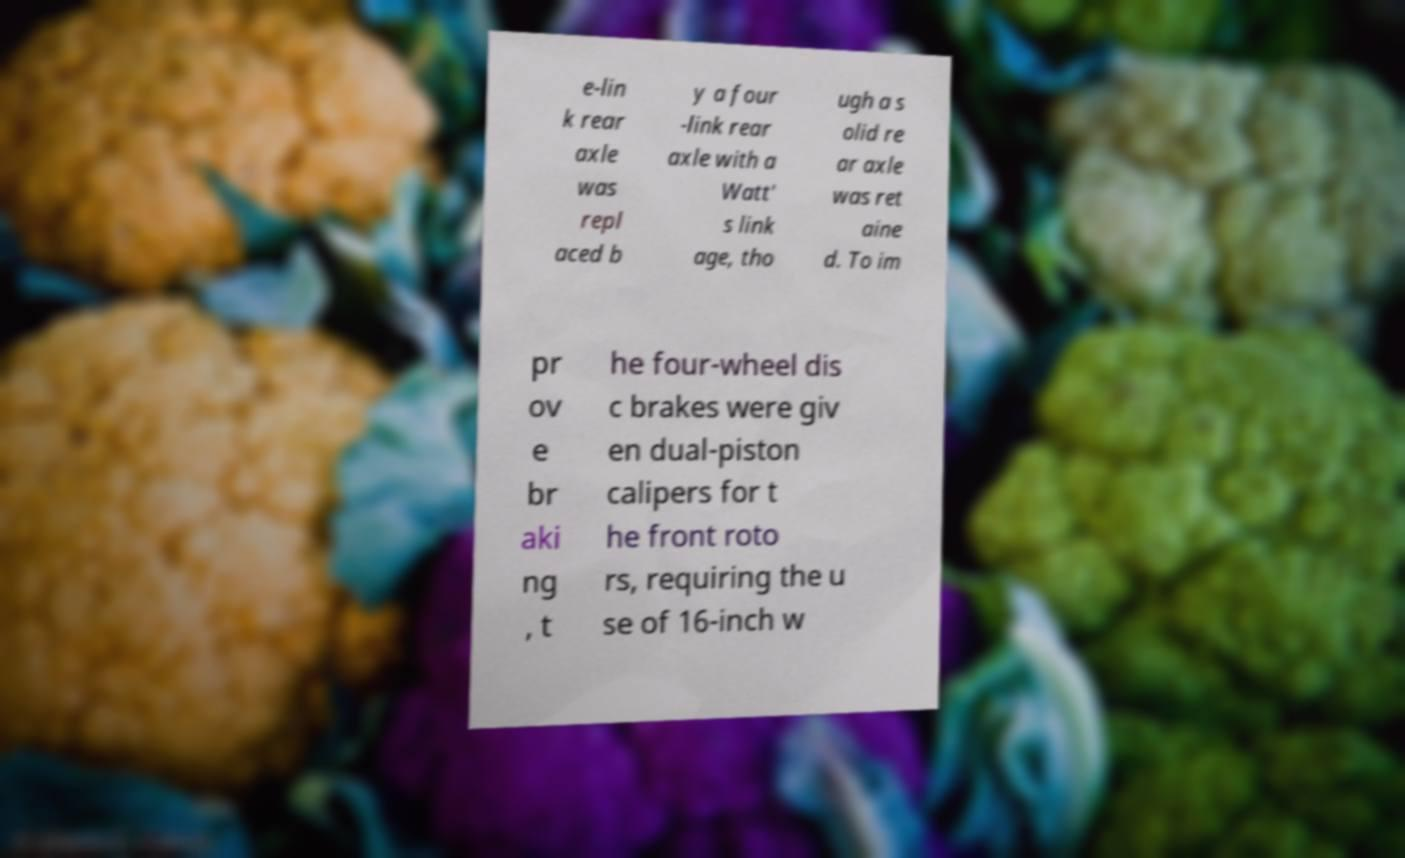Could you extract and type out the text from this image? e-lin k rear axle was repl aced b y a four -link rear axle with a Watt' s link age, tho ugh a s olid re ar axle was ret aine d. To im pr ov e br aki ng , t he four-wheel dis c brakes were giv en dual-piston calipers for t he front roto rs, requiring the u se of 16-inch w 